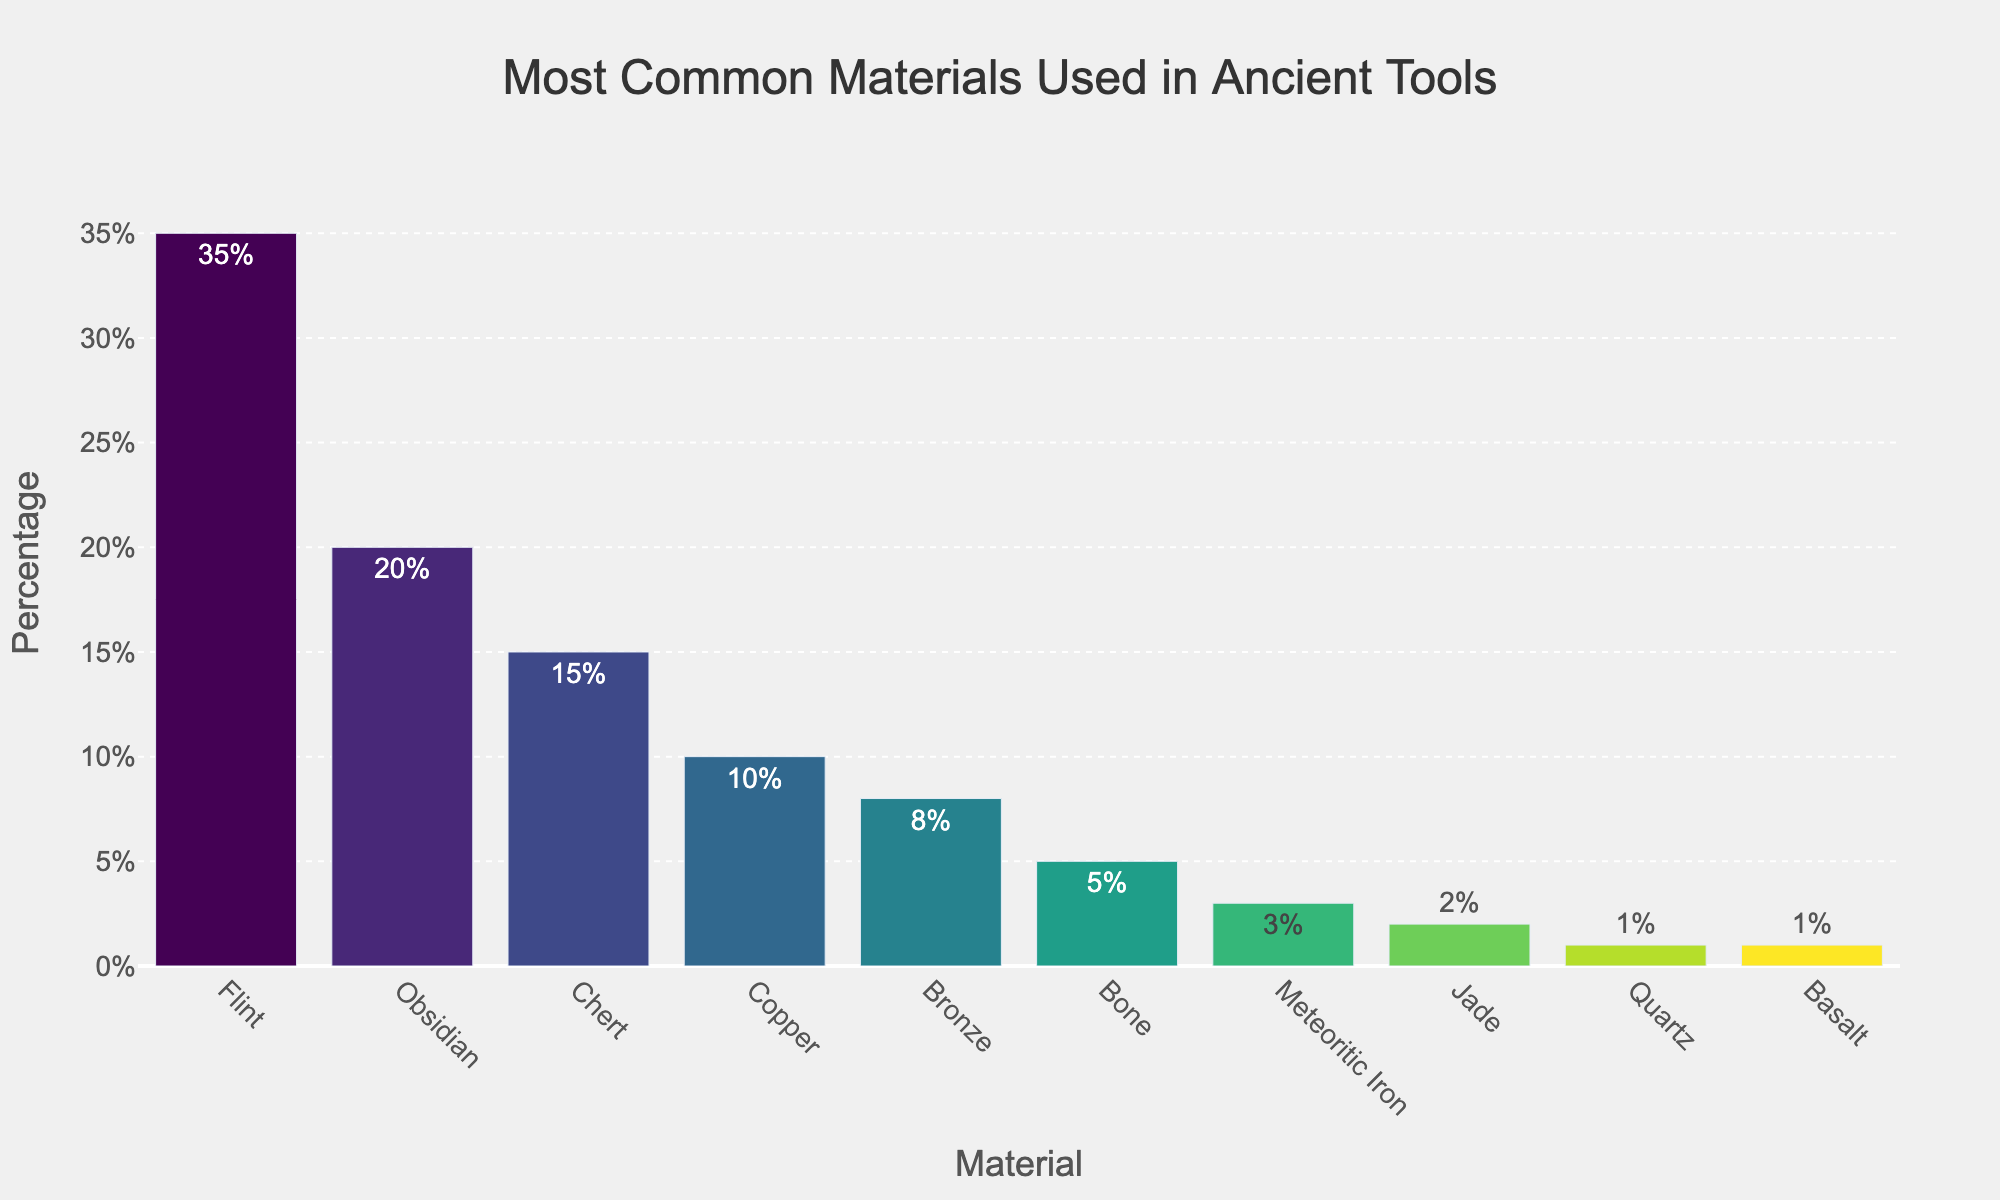What's the most common material used in ancient tools according to the chart? The bar representing Flint is the tallest and has the highest percentage.
Answer: Flint Which materials have a percentage higher than 15%? Flint, Obsidian, and Chert all have bars with percentages higher than 15%.
Answer: Flint, Obsidian, Chert What's the total percentage of organic materials (like Bone) used in ancient tools? Bone accounts for 5% of the total.
Answer: 5% How much greater is the percentage of Flint compared to Obsidian? Flint is at 35% and Obsidian is at 20%, so the difference is 35 - 20 = 15%.
Answer: 15% Which materials have a lower usage percentage than Bronze but higher than Quartz? Bone and Meteoritic Iron fall within this range, between Bronze's 8% and Quartz's 1%.
Answer: Bone, Meteoritic Iron By how much does the combined percentage of Chert and Copper exceed that of Obsidian? The combined percentage of Chert and Copper is 15 + 10 = 25%. Obsidian is at 20%, so the difference is 25 - 20 = 5%.
Answer: 5% How does the usage of Bronze compare to Copper? The percentage for Bronze is 8%, while Copper is 10%. Bronze is used 2% less than Copper.
Answer: 2% less If you were to group Copper and Bronze together as "Metal," where would it rank in terms of usage percentage compared to the other materials? Copper (10%) and Bronze (8%) together as "Metal" would sum to 18%, ranking it second after Flint.
Answer: Second What is the sum of percentages for all materials used in ancient tools? Sum of all the percentages given is 35 + 20 + 15 + 10 + 8 + 5 + 3 + 2 + 1 + 1 = 100%.
Answer: 100% How much less is the percentage of Meteoritic Iron compared to Bone? Bone is at 5% and Meteoritic Iron is at 3%, so the difference is 5 - 3 = 2%.
Answer: 2% 